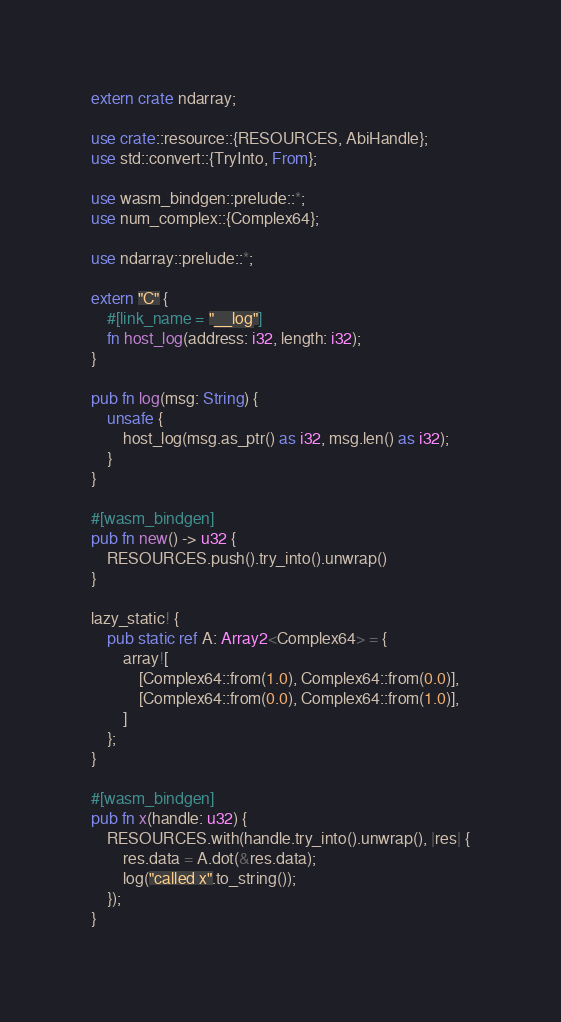<code> <loc_0><loc_0><loc_500><loc_500><_Rust_>extern crate ndarray;

use crate::resource::{RESOURCES, AbiHandle};
use std::convert::{TryInto, From};

use wasm_bindgen::prelude::*;
use num_complex::{Complex64};

use ndarray::prelude::*;

extern "C" {
    #[link_name = "__log"]
    fn host_log(address: i32, length: i32);
}

pub fn log(msg: String) {
    unsafe {
        host_log(msg.as_ptr() as i32, msg.len() as i32);
    }
}

#[wasm_bindgen]
pub fn new() -> u32 {
    RESOURCES.push().try_into().unwrap()
}

lazy_static! {
    pub static ref A: Array2<Complex64> = {
        array![
            [Complex64::from(1.0), Complex64::from(0.0)],
            [Complex64::from(0.0), Complex64::from(1.0)],
        ]
    };
}

#[wasm_bindgen]
pub fn x(handle: u32) {
    RESOURCES.with(handle.try_into().unwrap(), |res| {
        res.data = A.dot(&res.data);
        log("called x".to_string());
    });
}
</code> 